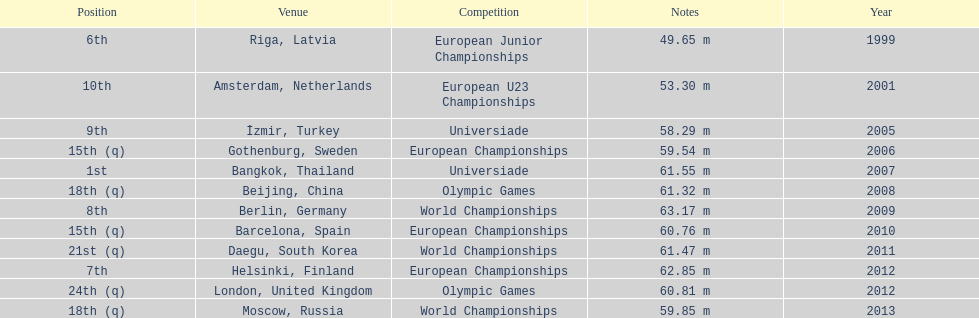Name two events in which mayer competed before he won the bangkok universiade. European Championships, Universiade. 